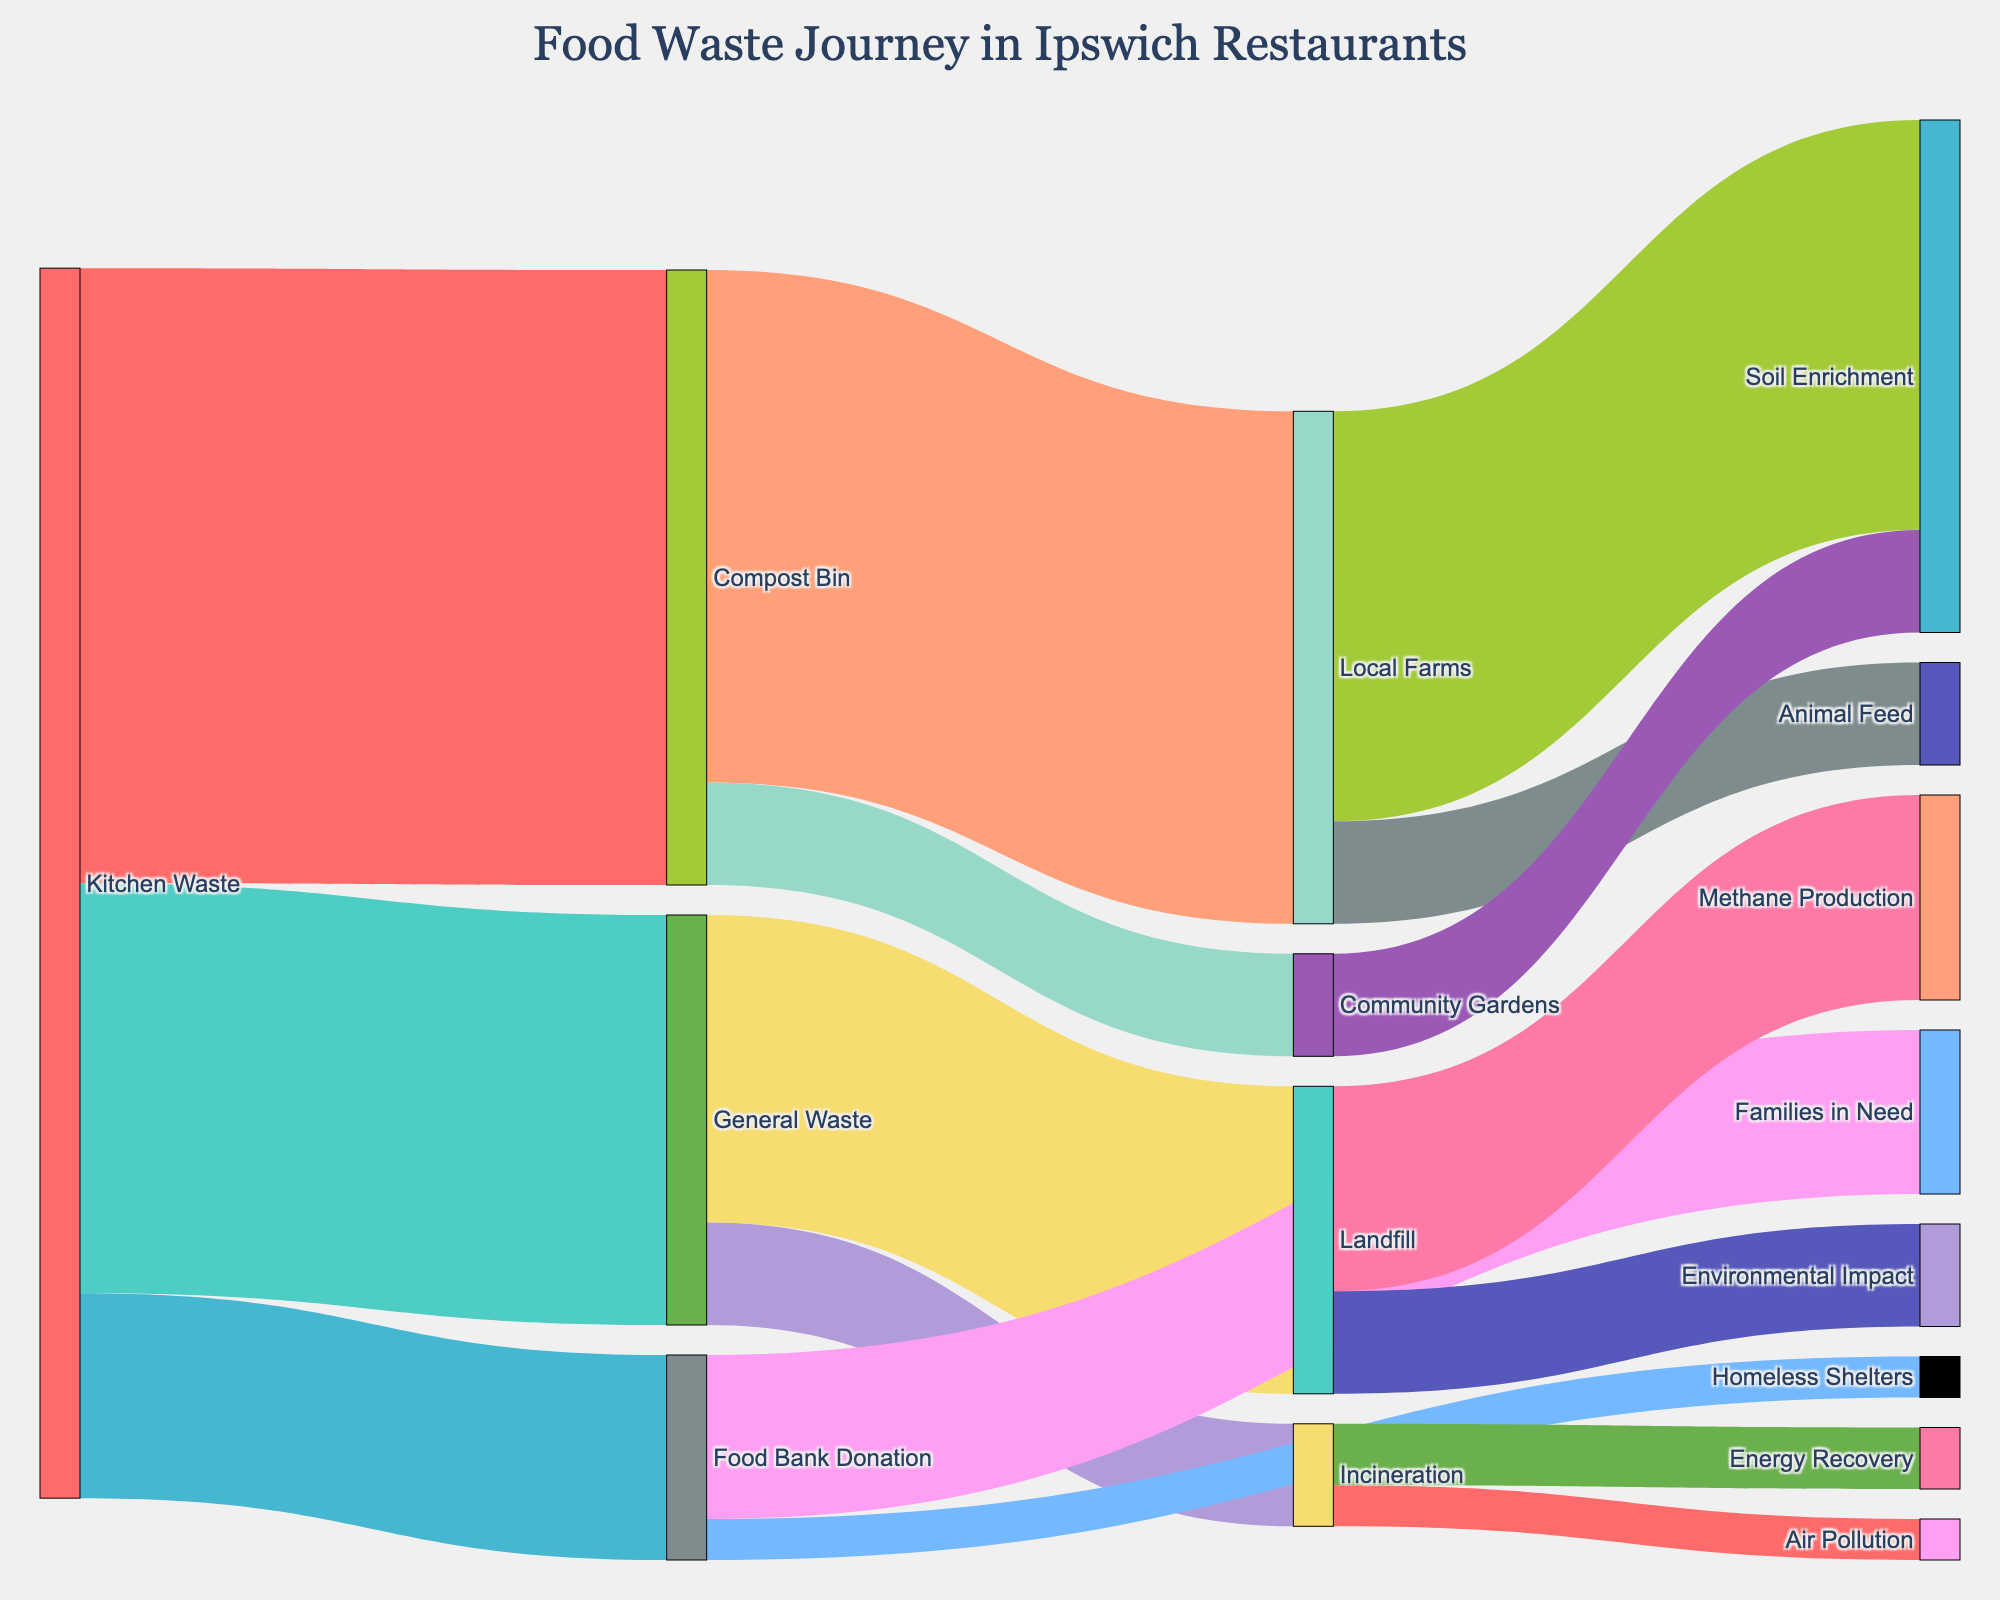How much kitchen waste goes to the compost bin? Look at the figure where the kitchen waste is directed towards various targets. The number next to the compost bin is 30.
Answer: 30 Which target receives the least amount of general waste? Compare the values of general waste directed to landfill and incineration. Incineration receives 5 units, which is less than the 15 units received by landfill.
Answer: Incineration What is the total amount of kitchen waste that gets recycled or reused? Add the values of kitchen waste directed to the compost bin and the food bank donation. This is 30 (compost bin) + 10 (food bank donation) = 40.
Answer: 40 Which target receives the highest amount of waste from the compost bin? Compare the values of compost bin waste directed to local farms and community gardens. Local farms receive 25 units, whereas community gardens receive 5 units.
Answer: Local Farms How does the amount of food waste sent to the landfill compare to that sent to incineration? Look at the figure to see that landfill receives 15 units of general waste, whereas incineration receives 5 units. 15 is greater than 5.
Answer: Landfill receives more than incineration What is the end destination of waste that goes to local farms? Trace the path from local farms to their respective targets. Local farms send 20 units to soil enrichment and 5 units to animal feed.
Answer: Soil enrichment and animal feed Which path shows the smallest value in the figure? Identify the path with the smallest number. This path is from food bank donation to homeless shelters, which shows a value of 2.
Answer: Food bank donation to homeless shelters How much food waste is directed from general waste to the landfill and incineration combined? Sum up the values of general waste going to landfill and incineration. This is 15 (landfill) + 5 (incineration) = 20.
Answer: 20 What is the largest number on the figure, and where does it occur? Identify the largest value in the figure and note its source and target. The largest value is 30, which occurs from kitchen waste to compost bin.
Answer: 30, from kitchen waste to compost bin What percentage of kitchen waste is donated to the food bank? Calculate the percentage of kitchen waste donated to the food bank by dividing the value for food bank donation by the total kitchen waste and multiplying by 100. (10 / 60) * 100 = 16.67%.
Answer: 16.67% 